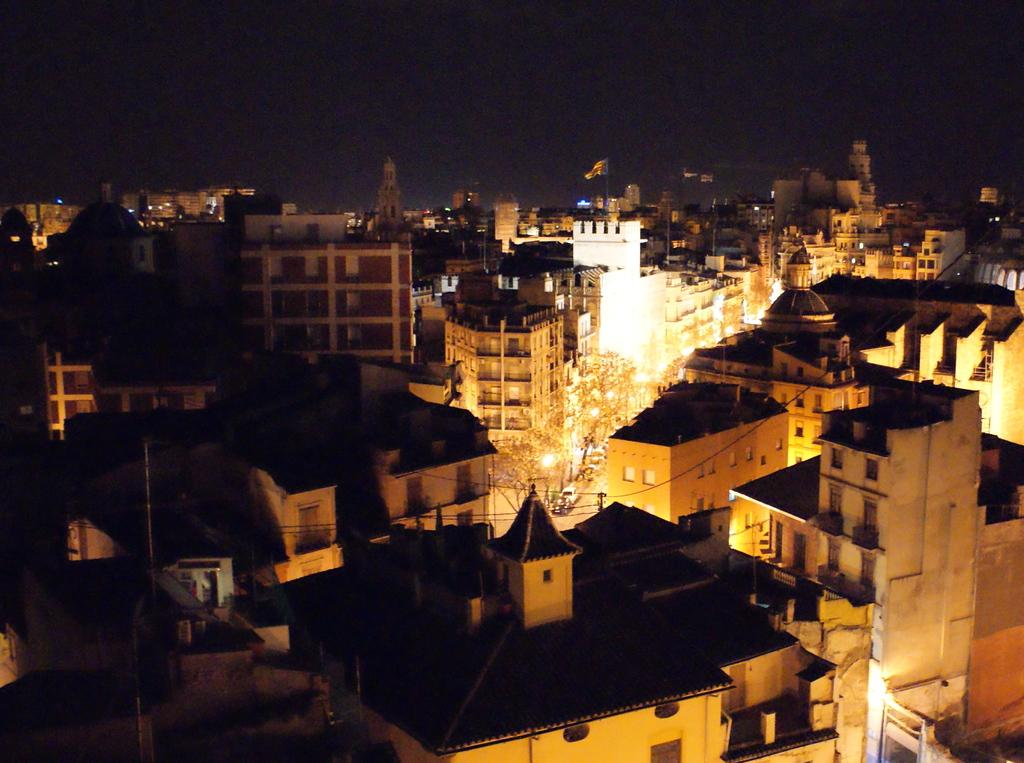What type of view is shown in the image? The image is an aerial view of a city. When was the image taken? The image was taken at night. What can be seen illuminating the path in the image? There are street lights in the middle of the path. How many buildings can be seen in the image? There are many buildings in the image. What type of air can be seen flowing through the buildings in the image? There is no air flow visible in the image; it is a still photograph of a city at night. 